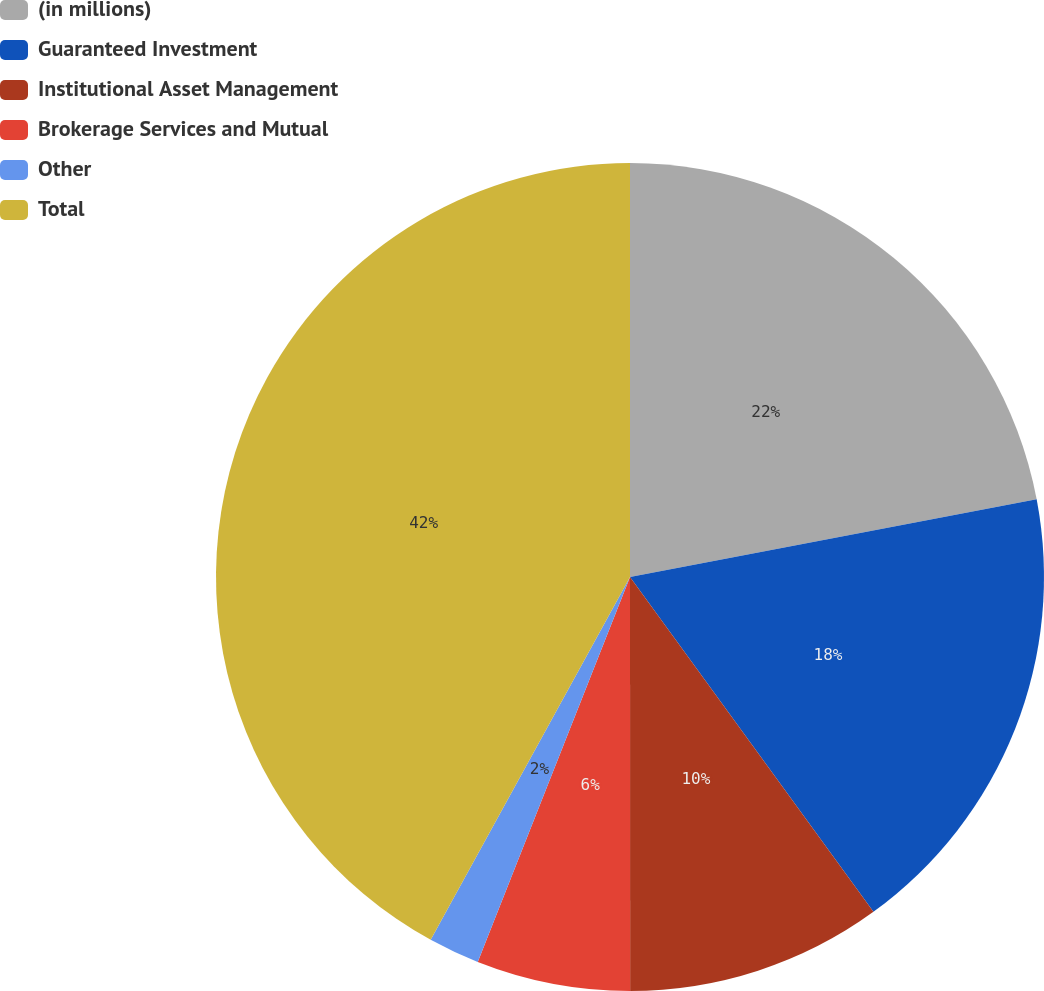Convert chart to OTSL. <chart><loc_0><loc_0><loc_500><loc_500><pie_chart><fcel>(in millions)<fcel>Guaranteed Investment<fcel>Institutional Asset Management<fcel>Brokerage Services and Mutual<fcel>Other<fcel>Total<nl><fcel>22.0%<fcel>18.0%<fcel>10.0%<fcel>6.0%<fcel>2.0%<fcel>42.01%<nl></chart> 